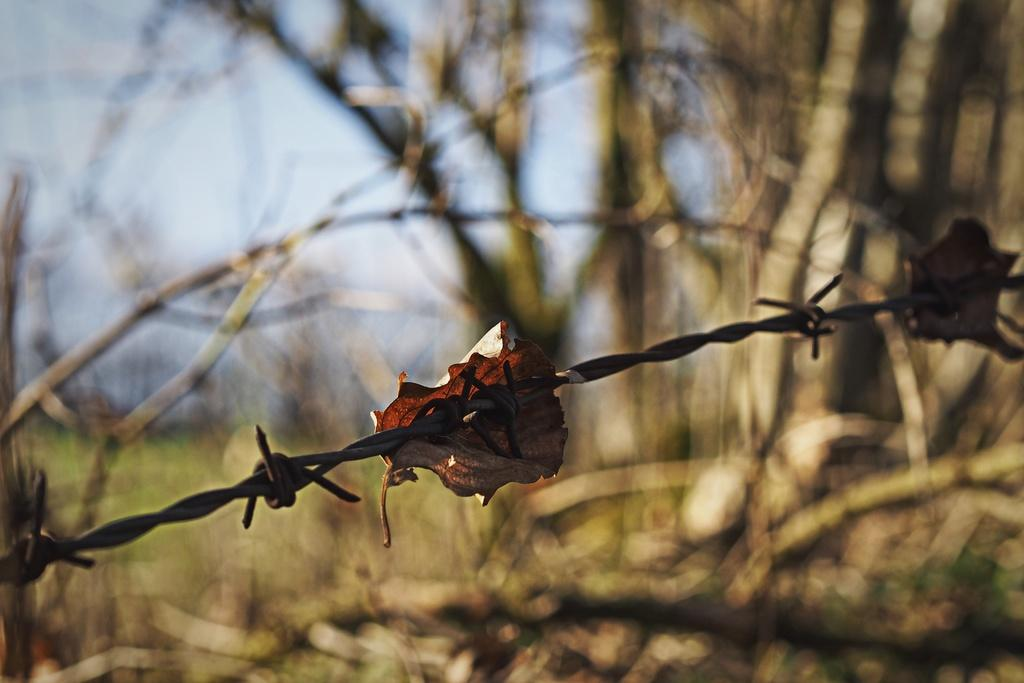What is located in the center of the image? There is a metal wire in the center of the image. What is attached to the metal wire? A leaf is attached to the metal wire. What can be seen in the background of the image? There are trees and the sky visible in the background of the image. What type of stamp can be seen on the leaf in the image? There is no stamp present on the leaf in the image. Is the leaf in motion in the image? The leaf is not in motion in the image; it is stationary on the metal wire. 